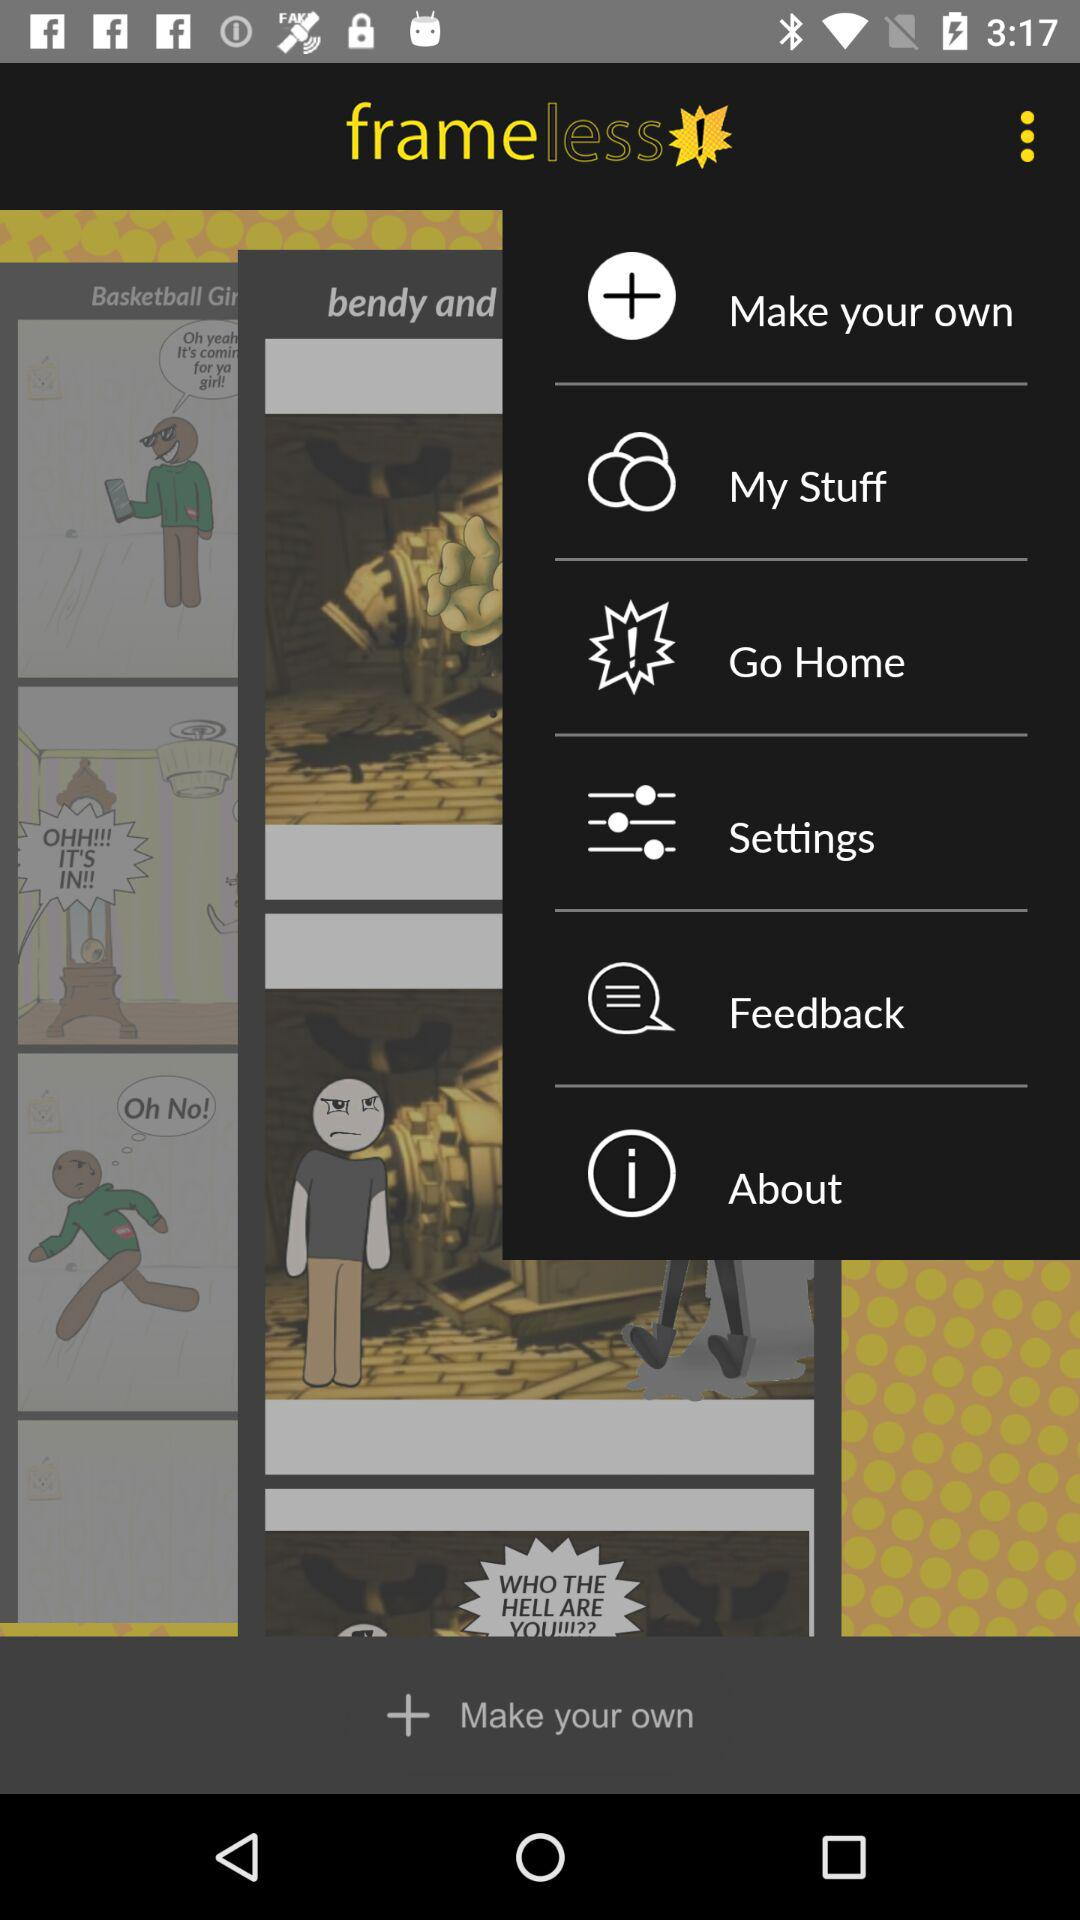What is the application name? The application name is "frameless". 